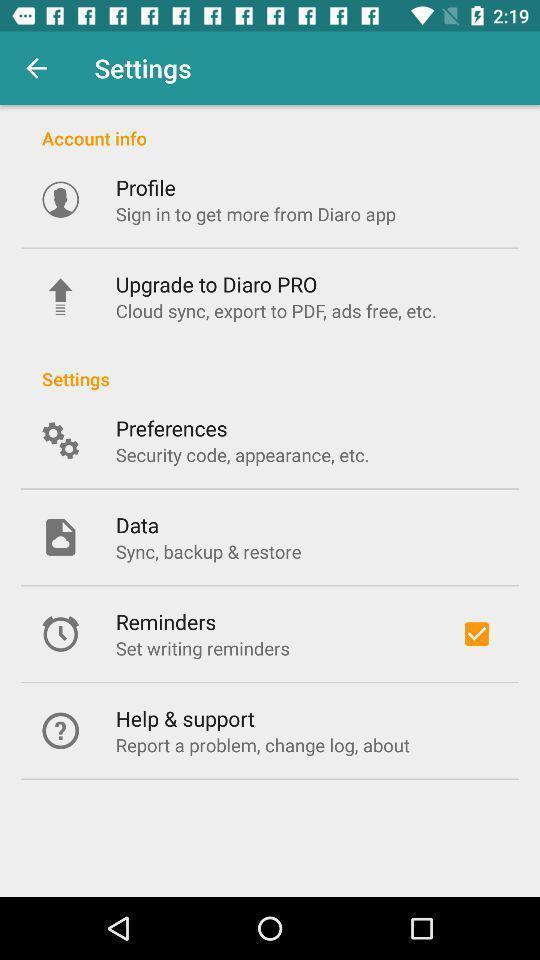Give me a narrative description of this picture. Setting page displaying the various options. 